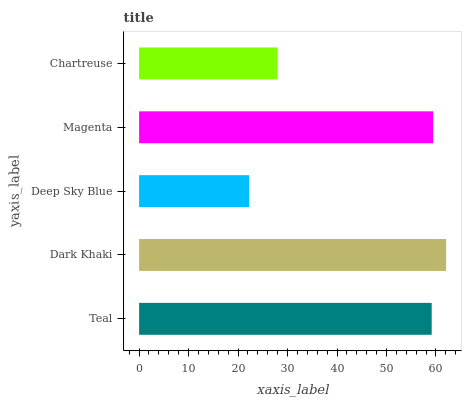Is Deep Sky Blue the minimum?
Answer yes or no. Yes. Is Dark Khaki the maximum?
Answer yes or no. Yes. Is Dark Khaki the minimum?
Answer yes or no. No. Is Deep Sky Blue the maximum?
Answer yes or no. No. Is Dark Khaki greater than Deep Sky Blue?
Answer yes or no. Yes. Is Deep Sky Blue less than Dark Khaki?
Answer yes or no. Yes. Is Deep Sky Blue greater than Dark Khaki?
Answer yes or no. No. Is Dark Khaki less than Deep Sky Blue?
Answer yes or no. No. Is Teal the high median?
Answer yes or no. Yes. Is Teal the low median?
Answer yes or no. Yes. Is Magenta the high median?
Answer yes or no. No. Is Deep Sky Blue the low median?
Answer yes or no. No. 